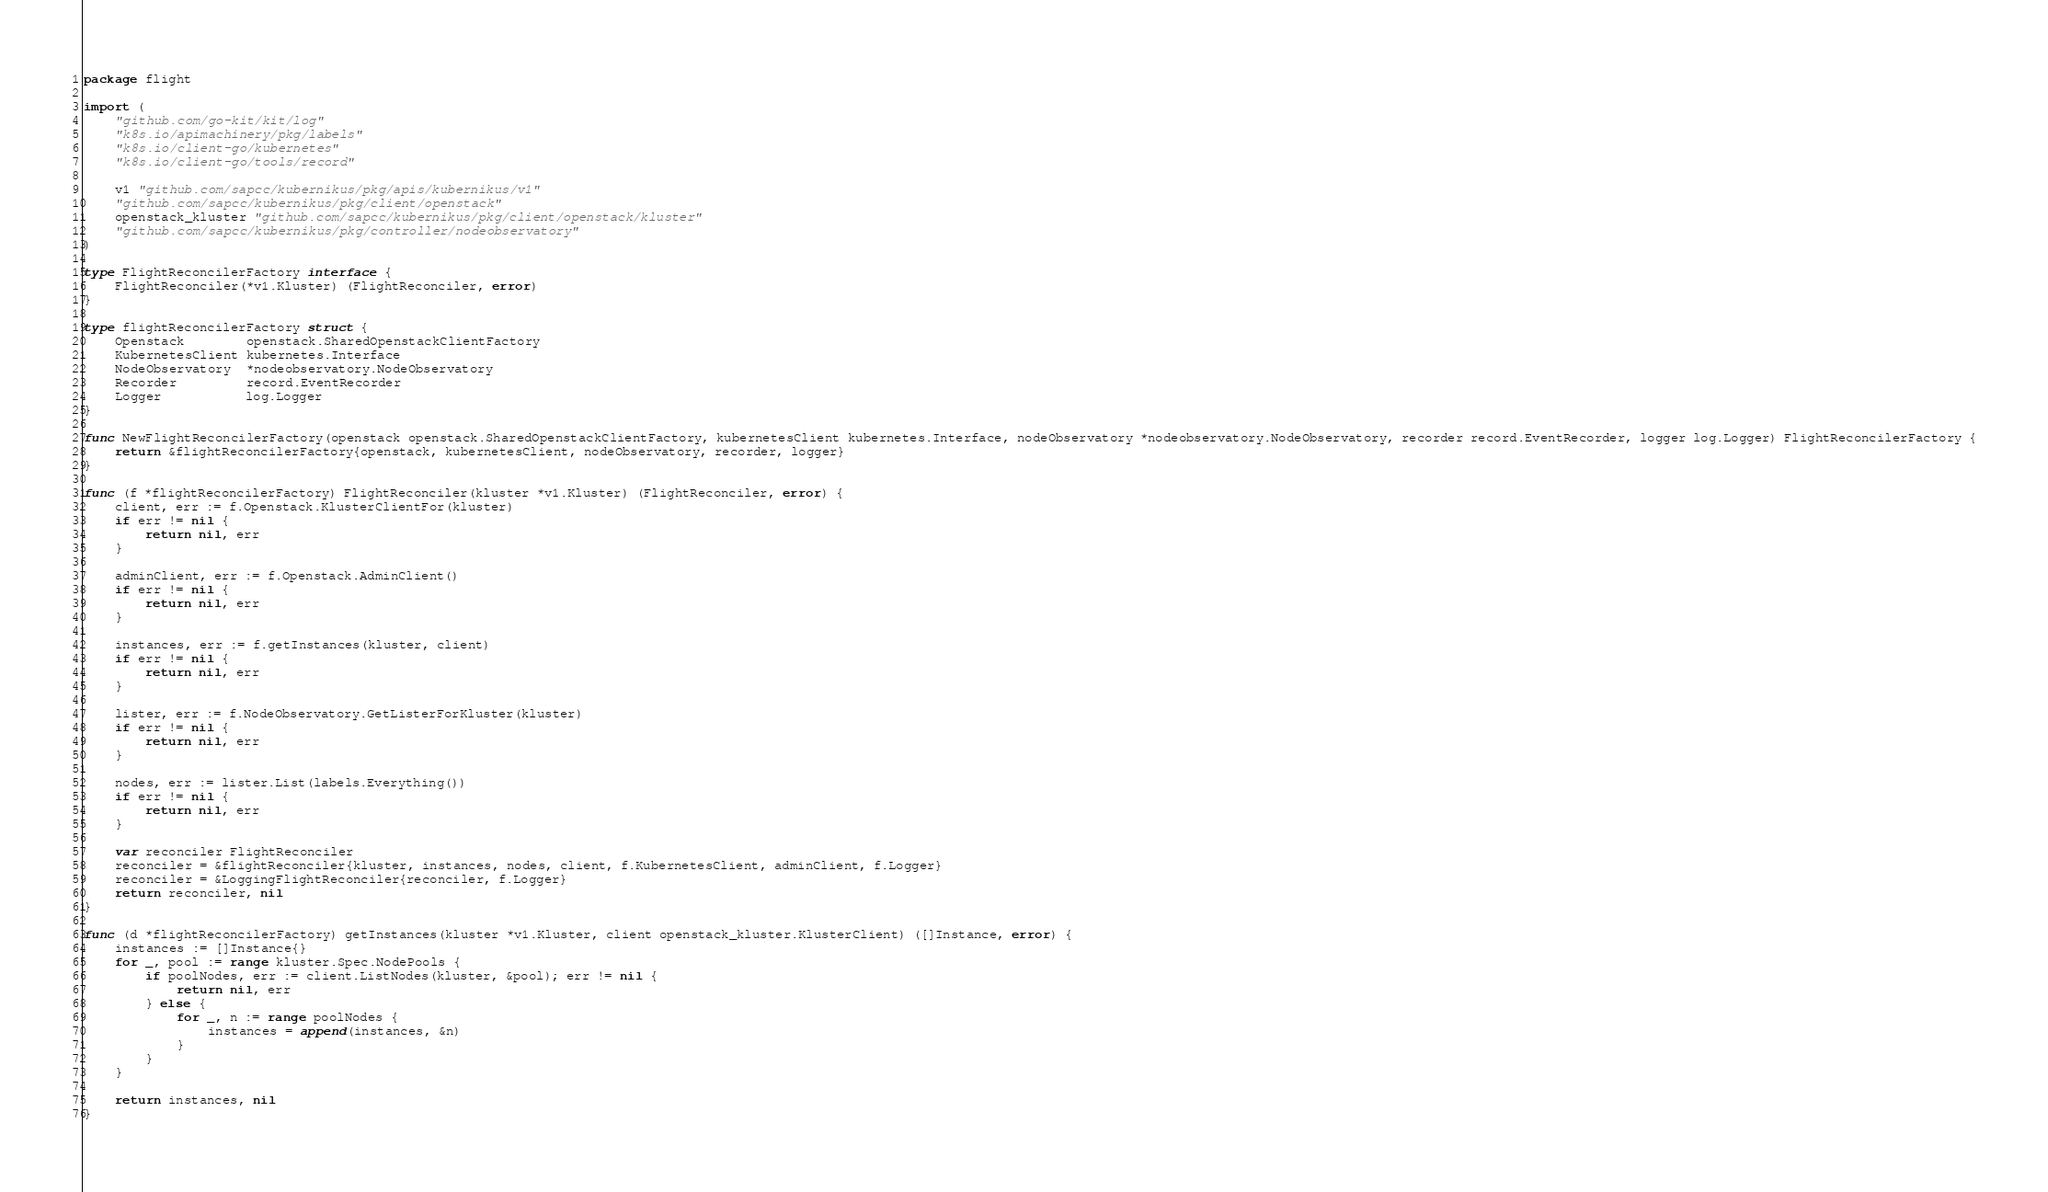Convert code to text. <code><loc_0><loc_0><loc_500><loc_500><_Go_>package flight

import (
	"github.com/go-kit/kit/log"
	"k8s.io/apimachinery/pkg/labels"
	"k8s.io/client-go/kubernetes"
	"k8s.io/client-go/tools/record"

	v1 "github.com/sapcc/kubernikus/pkg/apis/kubernikus/v1"
	"github.com/sapcc/kubernikus/pkg/client/openstack"
	openstack_kluster "github.com/sapcc/kubernikus/pkg/client/openstack/kluster"
	"github.com/sapcc/kubernikus/pkg/controller/nodeobservatory"
)

type FlightReconcilerFactory interface {
	FlightReconciler(*v1.Kluster) (FlightReconciler, error)
}

type flightReconcilerFactory struct {
	Openstack        openstack.SharedOpenstackClientFactory
	KubernetesClient kubernetes.Interface
	NodeObservatory  *nodeobservatory.NodeObservatory
	Recorder         record.EventRecorder
	Logger           log.Logger
}

func NewFlightReconcilerFactory(openstack openstack.SharedOpenstackClientFactory, kubernetesClient kubernetes.Interface, nodeObservatory *nodeobservatory.NodeObservatory, recorder record.EventRecorder, logger log.Logger) FlightReconcilerFactory {
	return &flightReconcilerFactory{openstack, kubernetesClient, nodeObservatory, recorder, logger}
}

func (f *flightReconcilerFactory) FlightReconciler(kluster *v1.Kluster) (FlightReconciler, error) {
	client, err := f.Openstack.KlusterClientFor(kluster)
	if err != nil {
		return nil, err
	}

	adminClient, err := f.Openstack.AdminClient()
	if err != nil {
		return nil, err
	}

	instances, err := f.getInstances(kluster, client)
	if err != nil {
		return nil, err
	}

	lister, err := f.NodeObservatory.GetListerForKluster(kluster)
	if err != nil {
		return nil, err
	}

	nodes, err := lister.List(labels.Everything())
	if err != nil {
		return nil, err
	}

	var reconciler FlightReconciler
	reconciler = &flightReconciler{kluster, instances, nodes, client, f.KubernetesClient, adminClient, f.Logger}
	reconciler = &LoggingFlightReconciler{reconciler, f.Logger}
	return reconciler, nil
}

func (d *flightReconcilerFactory) getInstances(kluster *v1.Kluster, client openstack_kluster.KlusterClient) ([]Instance, error) {
	instances := []Instance{}
	for _, pool := range kluster.Spec.NodePools {
		if poolNodes, err := client.ListNodes(kluster, &pool); err != nil {
			return nil, err
		} else {
			for _, n := range poolNodes {
				instances = append(instances, &n)
			}
		}
	}

	return instances, nil
}
</code> 